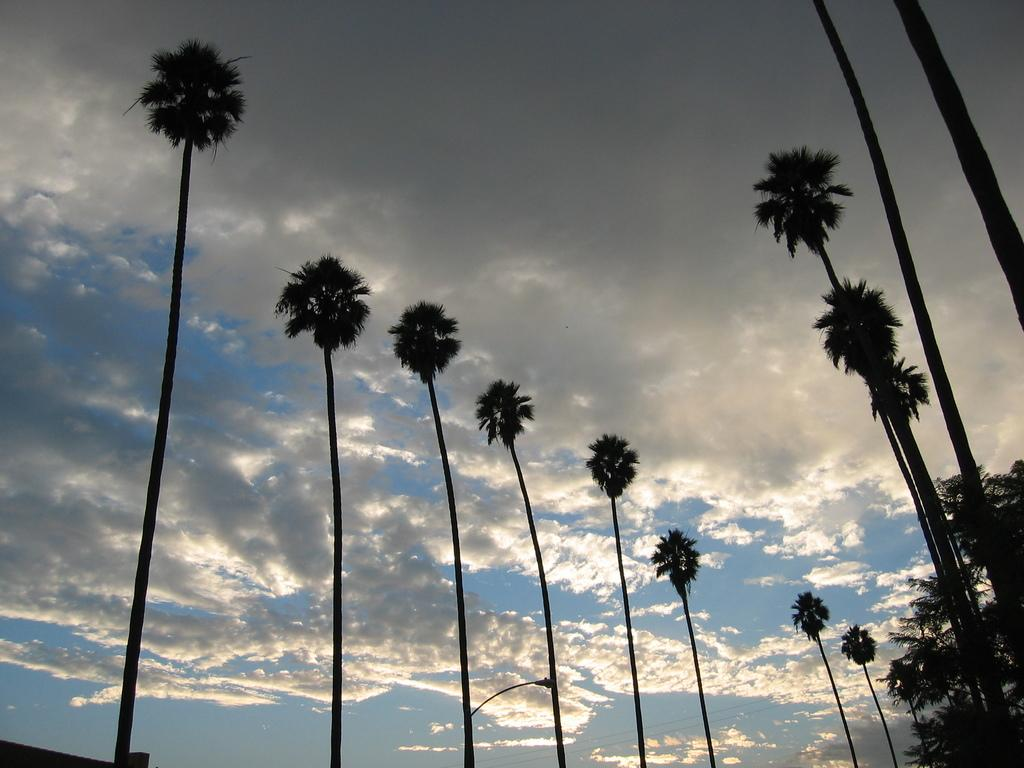What type of vegetation can be seen in the image? There are trees in the image. What is visible in the background of the image? The sky is visible in the background of the image. What can be observed in the sky? Clouds are present in the sky. Where is the nearest shop to buy an answer in the image? There is no shop or concept of buying an answer present in the image. 